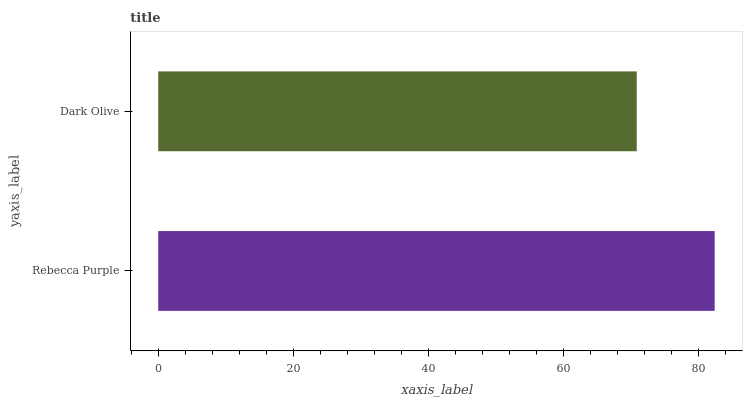Is Dark Olive the minimum?
Answer yes or no. Yes. Is Rebecca Purple the maximum?
Answer yes or no. Yes. Is Dark Olive the maximum?
Answer yes or no. No. Is Rebecca Purple greater than Dark Olive?
Answer yes or no. Yes. Is Dark Olive less than Rebecca Purple?
Answer yes or no. Yes. Is Dark Olive greater than Rebecca Purple?
Answer yes or no. No. Is Rebecca Purple less than Dark Olive?
Answer yes or no. No. Is Rebecca Purple the high median?
Answer yes or no. Yes. Is Dark Olive the low median?
Answer yes or no. Yes. Is Dark Olive the high median?
Answer yes or no. No. Is Rebecca Purple the low median?
Answer yes or no. No. 